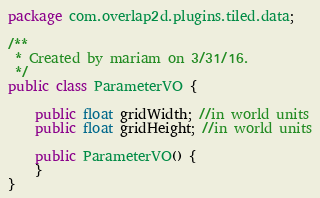Convert code to text. <code><loc_0><loc_0><loc_500><loc_500><_Java_>package com.overlap2d.plugins.tiled.data;

/**
 * Created by mariam on 3/31/16.
 */
public class ParameterVO {

    public float gridWidth; //in world units
    public float gridHeight; //in world units

    public ParameterVO() {
    }
}
</code> 